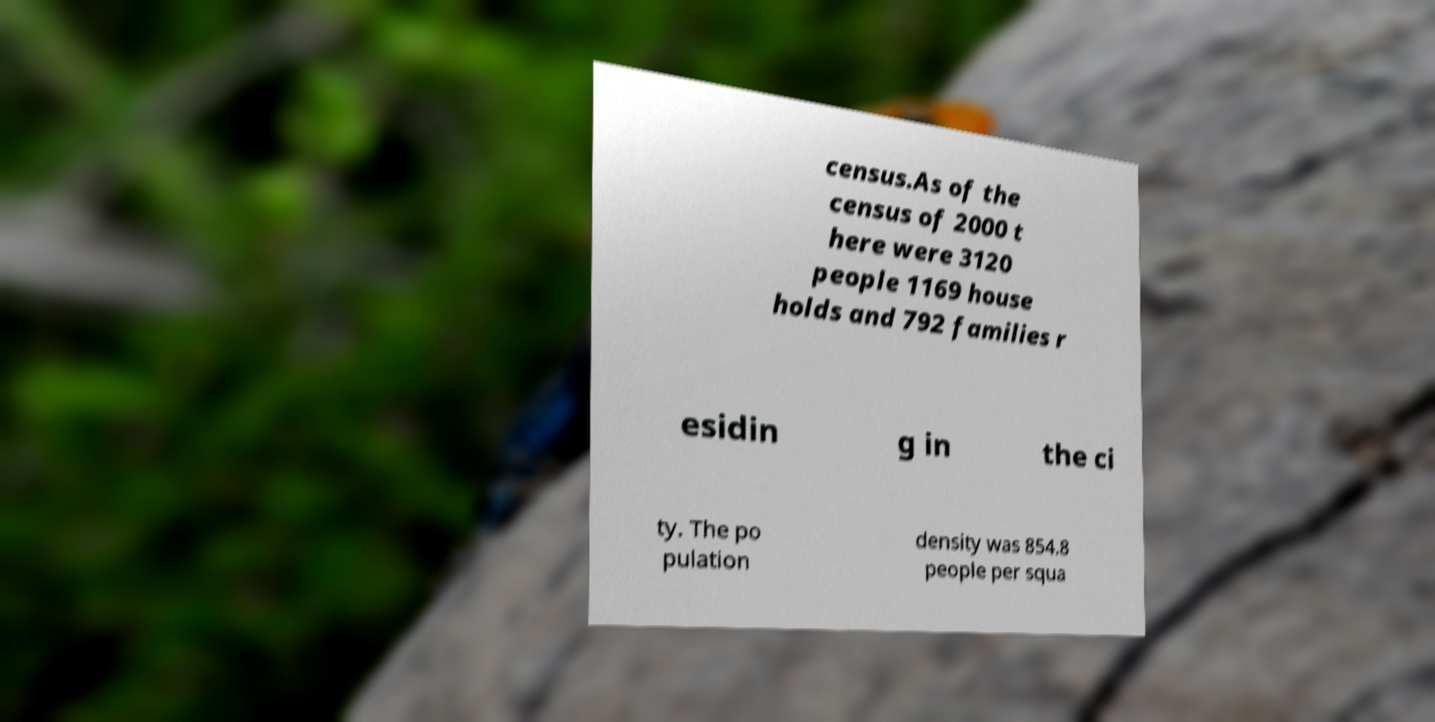Can you read and provide the text displayed in the image?This photo seems to have some interesting text. Can you extract and type it out for me? census.As of the census of 2000 t here were 3120 people 1169 house holds and 792 families r esidin g in the ci ty. The po pulation density was 854.8 people per squa 